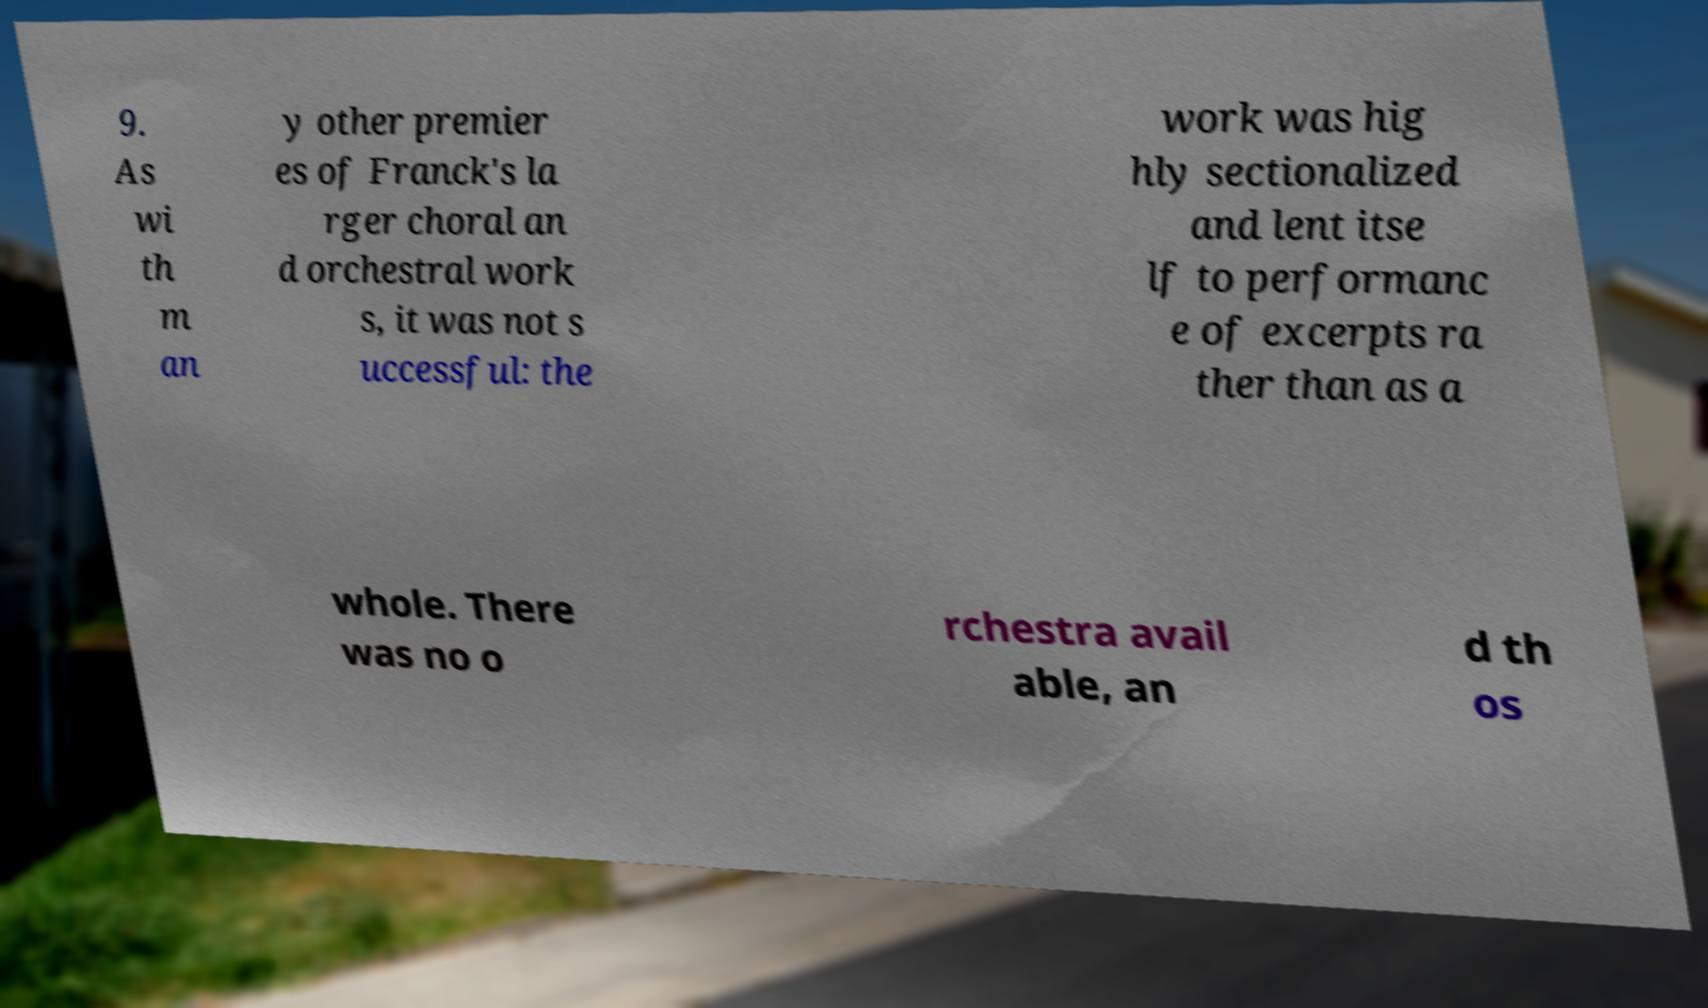For documentation purposes, I need the text within this image transcribed. Could you provide that? 9. As wi th m an y other premier es of Franck's la rger choral an d orchestral work s, it was not s uccessful: the work was hig hly sectionalized and lent itse lf to performanc e of excerpts ra ther than as a whole. There was no o rchestra avail able, an d th os 